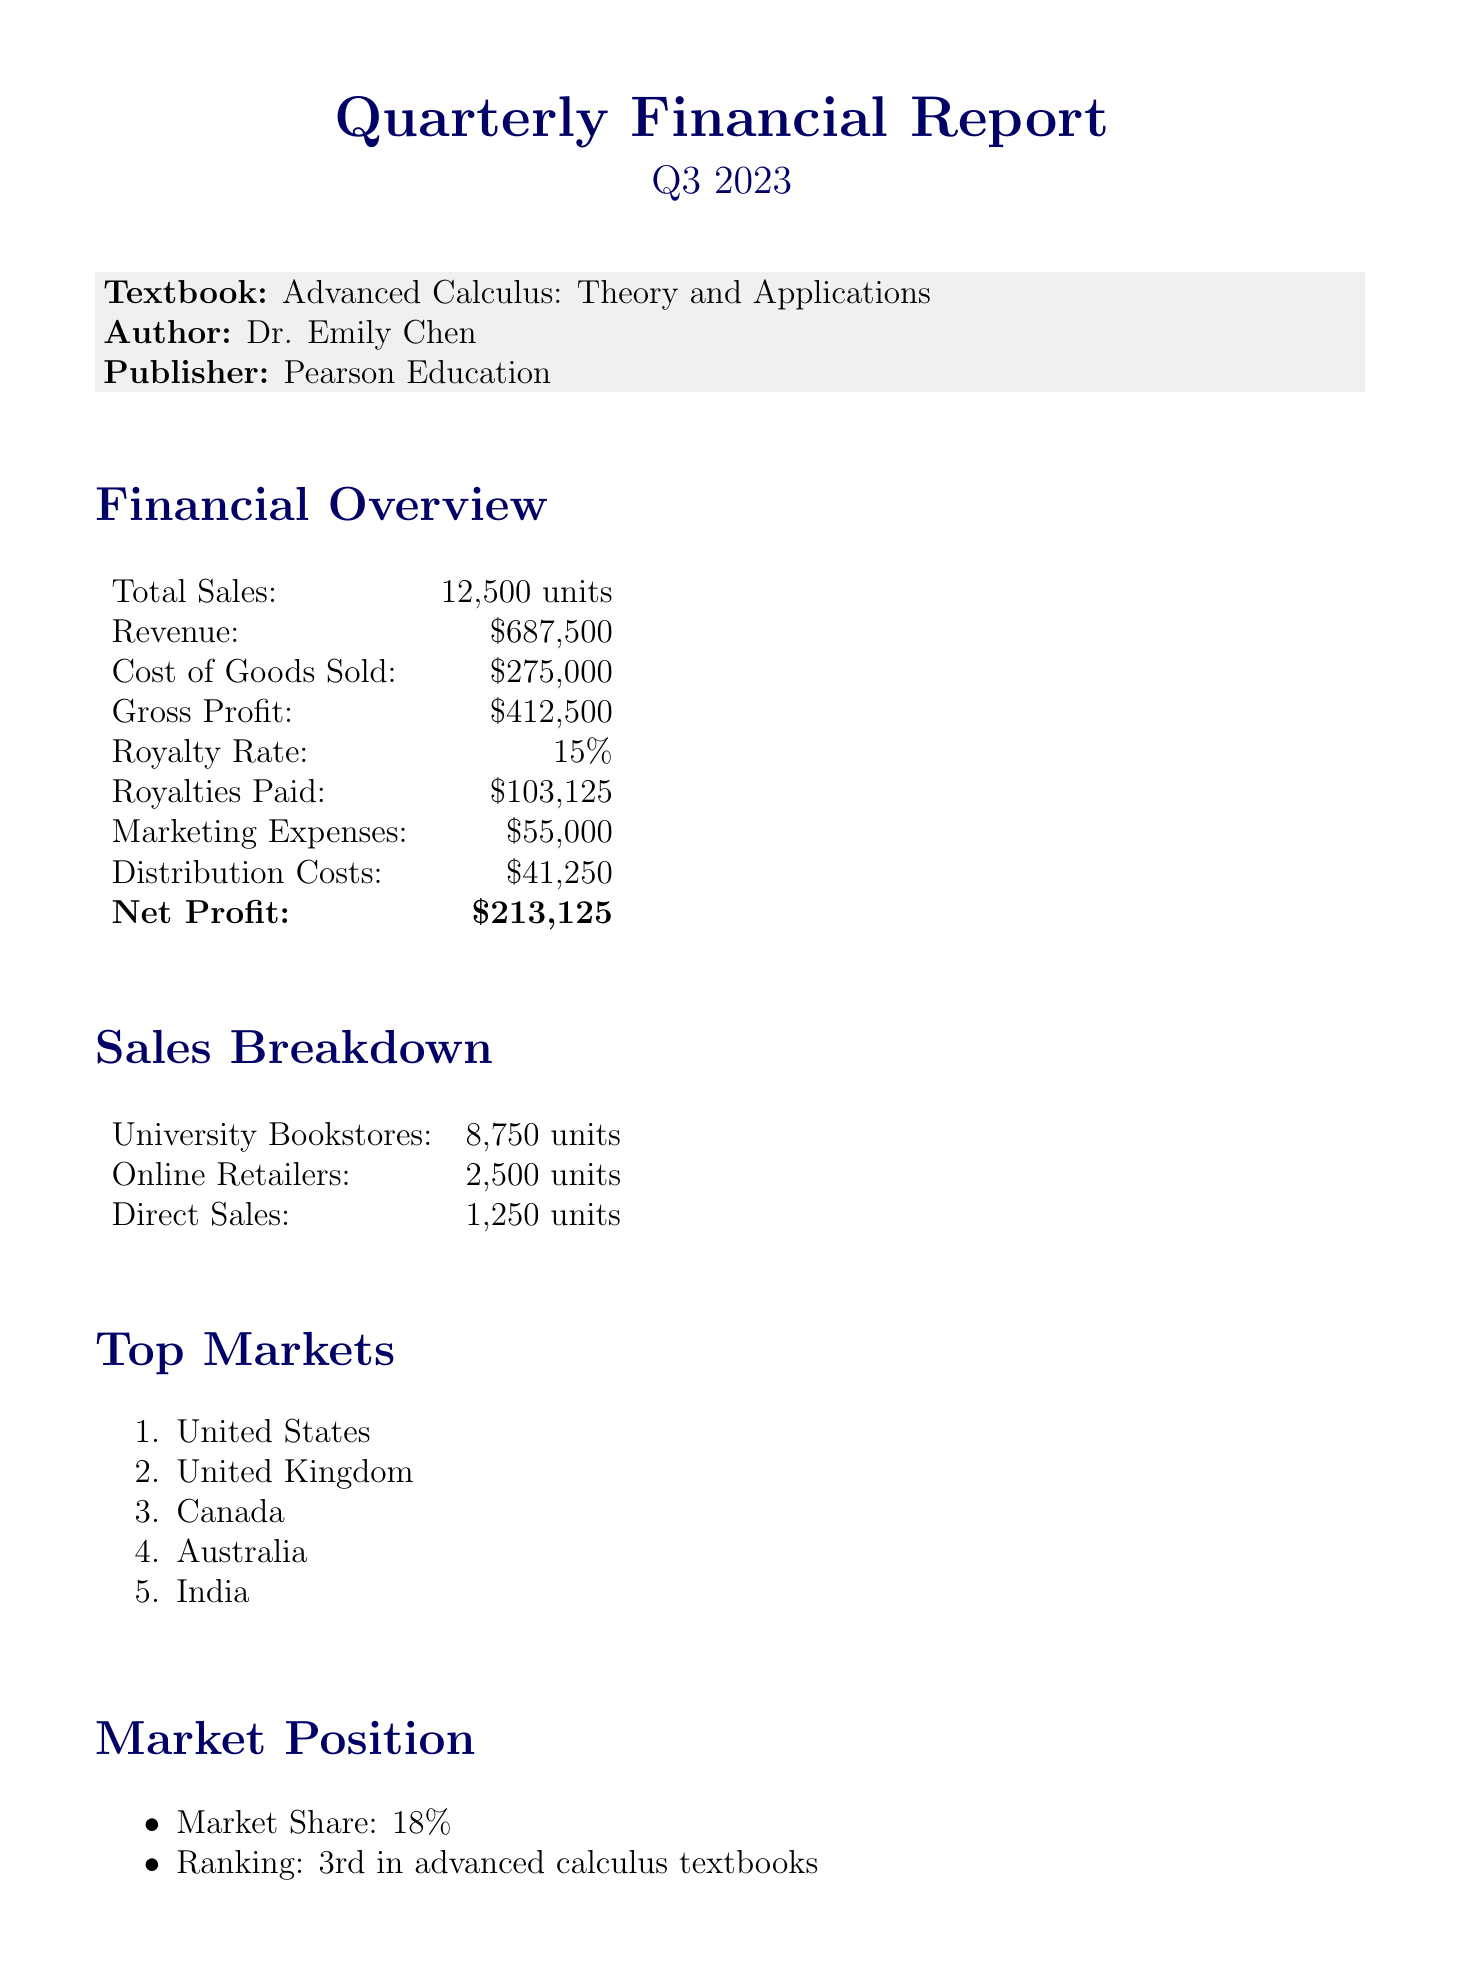What is the total number of units sold? The total number of units sold is given under 'Total Sales' in the financial overview, which is 12,500 units.
Answer: 12,500 units What is the gross profit? The gross profit is listed in the financial overview as the difference between revenue and cost of goods sold, which is $412,500.
Answer: $412,500 What percentage is the royalty rate? The royalty rate is explicitly stated in the financial overview as 15%.
Answer: 15% How much were the royalties paid? The document specifies the royalties paid as $103,125 in the financial overview.
Answer: $103,125 Which is the highest sales channel? The highest sales channel is mentioned in the sales breakdown, being university bookstores with 8,750 units sold.
Answer: University Bookstores What are the anticipated new adoptions? The document states that the anticipated new adoptions are 15, which is a future projection.
Answer: 15 What is the expected growth rate? The expected growth rate is provided in the future projections section as 5%.
Answer: 5% What is the market share percentage? The market share percentage is detailed in the market position section, which is 18%.
Answer: 18% Which ranking is the textbook in advanced calculus textbooks? The ranking is specified in the market position section as 3rd in advanced calculus textbooks.
Answer: 3rd 